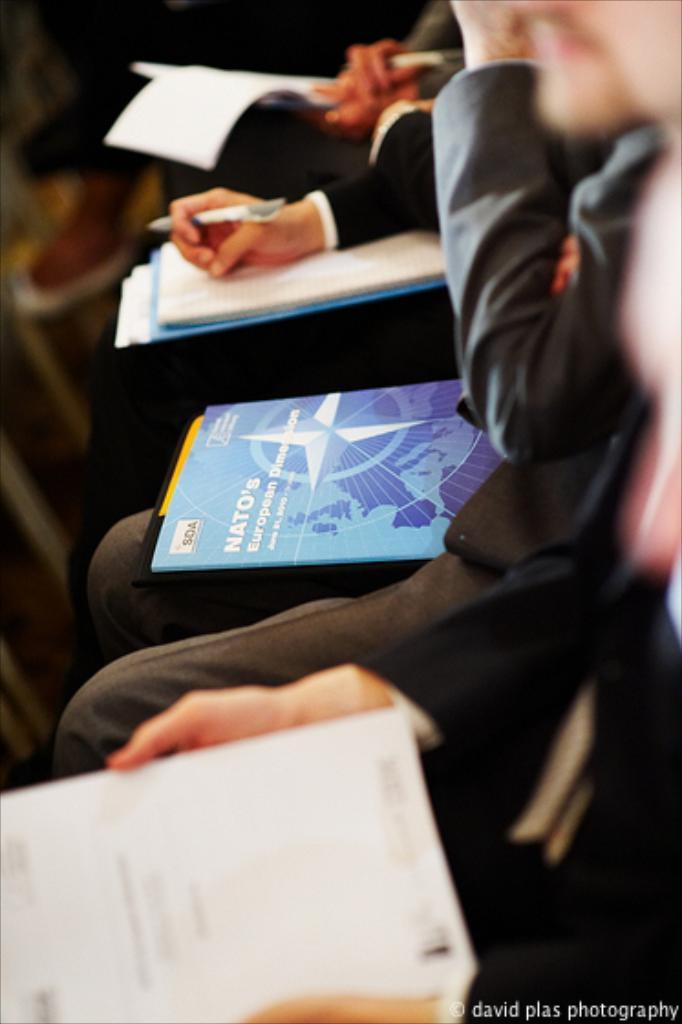What is the main subject of the image? The main subject of the image is a group of people. What are the people in the image doing? The people are sitting in the image. What are the people holding in their hands? The people are holding objects in their hands. Can you describe any text present in the image? There is some text at the bottom right of the image. Can you describe the thickness of the wool in the image? There is no wool present in the image; it features a group of people sitting and holding objects. How does the fog affect the visibility of the people in the image? There is no fog present in the image, so it does not affect the visibility of the people. 